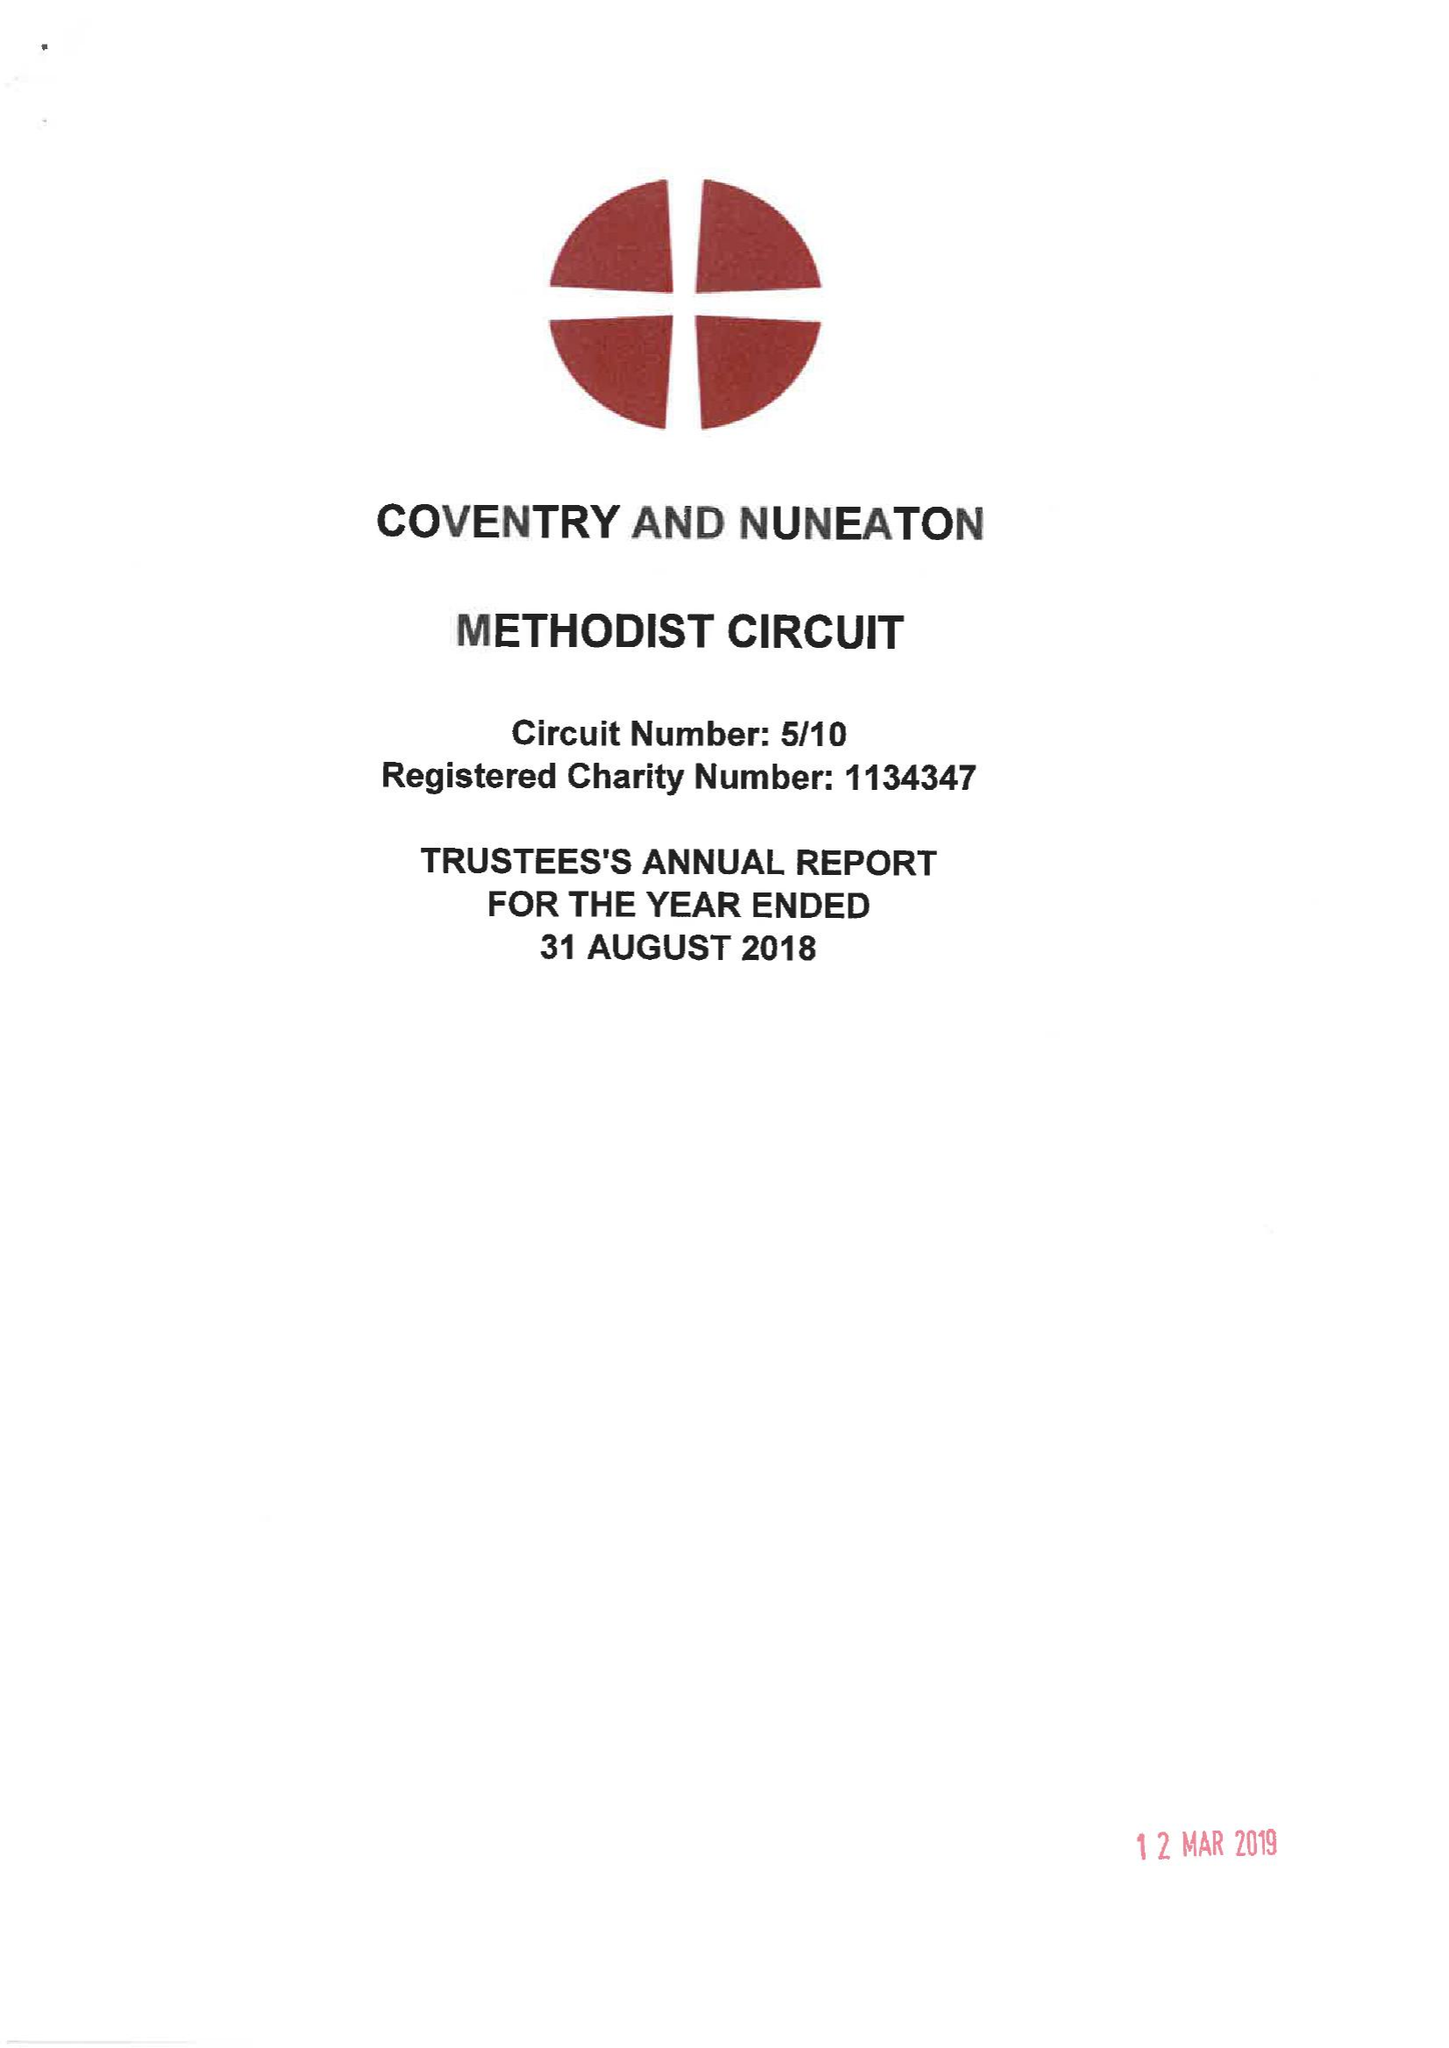What is the value for the charity_number?
Answer the question using a single word or phrase. 1134347 